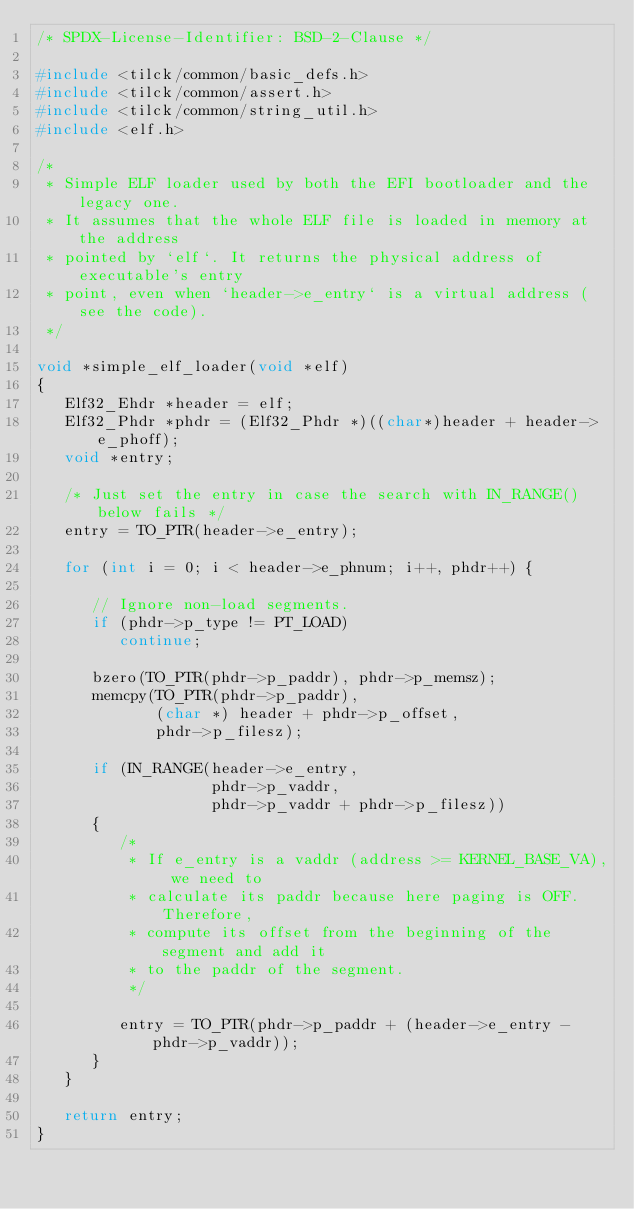Convert code to text. <code><loc_0><loc_0><loc_500><loc_500><_C_>/* SPDX-License-Identifier: BSD-2-Clause */

#include <tilck/common/basic_defs.h>
#include <tilck/common/assert.h>
#include <tilck/common/string_util.h>
#include <elf.h>

/*
 * Simple ELF loader used by both the EFI bootloader and the legacy one.
 * It assumes that the whole ELF file is loaded in memory at the address
 * pointed by `elf`. It returns the physical address of executable's entry
 * point, even when `header->e_entry` is a virtual address (see the code).
 */

void *simple_elf_loader(void *elf)
{
   Elf32_Ehdr *header = elf;
   Elf32_Phdr *phdr = (Elf32_Phdr *)((char*)header + header->e_phoff);
   void *entry;

   /* Just set the entry in case the search with IN_RANGE() below fails */
   entry = TO_PTR(header->e_entry);

   for (int i = 0; i < header->e_phnum; i++, phdr++) {

      // Ignore non-load segments.
      if (phdr->p_type != PT_LOAD)
         continue;

      bzero(TO_PTR(phdr->p_paddr), phdr->p_memsz);
      memcpy(TO_PTR(phdr->p_paddr),
             (char *) header + phdr->p_offset,
             phdr->p_filesz);

      if (IN_RANGE(header->e_entry,
                   phdr->p_vaddr,
                   phdr->p_vaddr + phdr->p_filesz))
      {
         /*
          * If e_entry is a vaddr (address >= KERNEL_BASE_VA), we need to
          * calculate its paddr because here paging is OFF. Therefore,
          * compute its offset from the beginning of the segment and add it
          * to the paddr of the segment.
          */

         entry = TO_PTR(phdr->p_paddr + (header->e_entry - phdr->p_vaddr));
      }
   }

   return entry;
}
</code> 